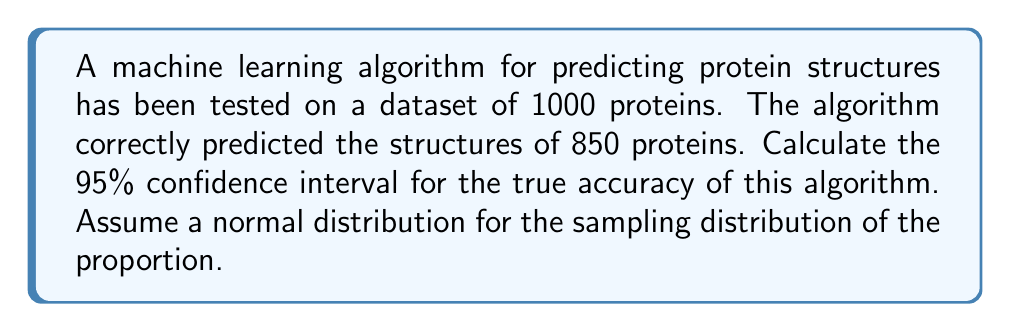Help me with this question. To calculate the confidence interval for the proportion (accuracy) of a machine learning algorithm, we'll follow these steps:

1. Identify the sample proportion (p̂):
   $$\hat{p} = \frac{\text{Number of correct predictions}}{\text{Total number of predictions}} = \frac{850}{1000} = 0.85$$

2. Calculate the standard error (SE) of the proportion:
   $$SE = \sqrt{\frac{\hat{p}(1-\hat{p})}{n}} = \sqrt{\frac{0.85(1-0.85)}{1000}} = \sqrt{\frac{0.1275}{1000}} \approx 0.0113$$

3. Determine the z-score for a 95% confidence interval:
   The z-score for a 95% CI is 1.96 (rounded to two decimal places).

4. Calculate the margin of error:
   $$\text{Margin of Error} = z \times SE = 1.96 \times 0.0113 \approx 0.0221$$

5. Compute the confidence interval:
   Lower bound: $\hat{p} - \text{Margin of Error} = 0.85 - 0.0221 \approx 0.8279$
   Upper bound: $\hat{p} + \text{Margin of Error} = 0.85 + 0.0221 \approx 0.8721$

Therefore, we can be 95% confident that the true accuracy of the machine learning algorithm for predicting protein structures lies between 82.79% and 87.21%.
Answer: (0.8279, 0.8721) or (82.79%, 87.21%) 